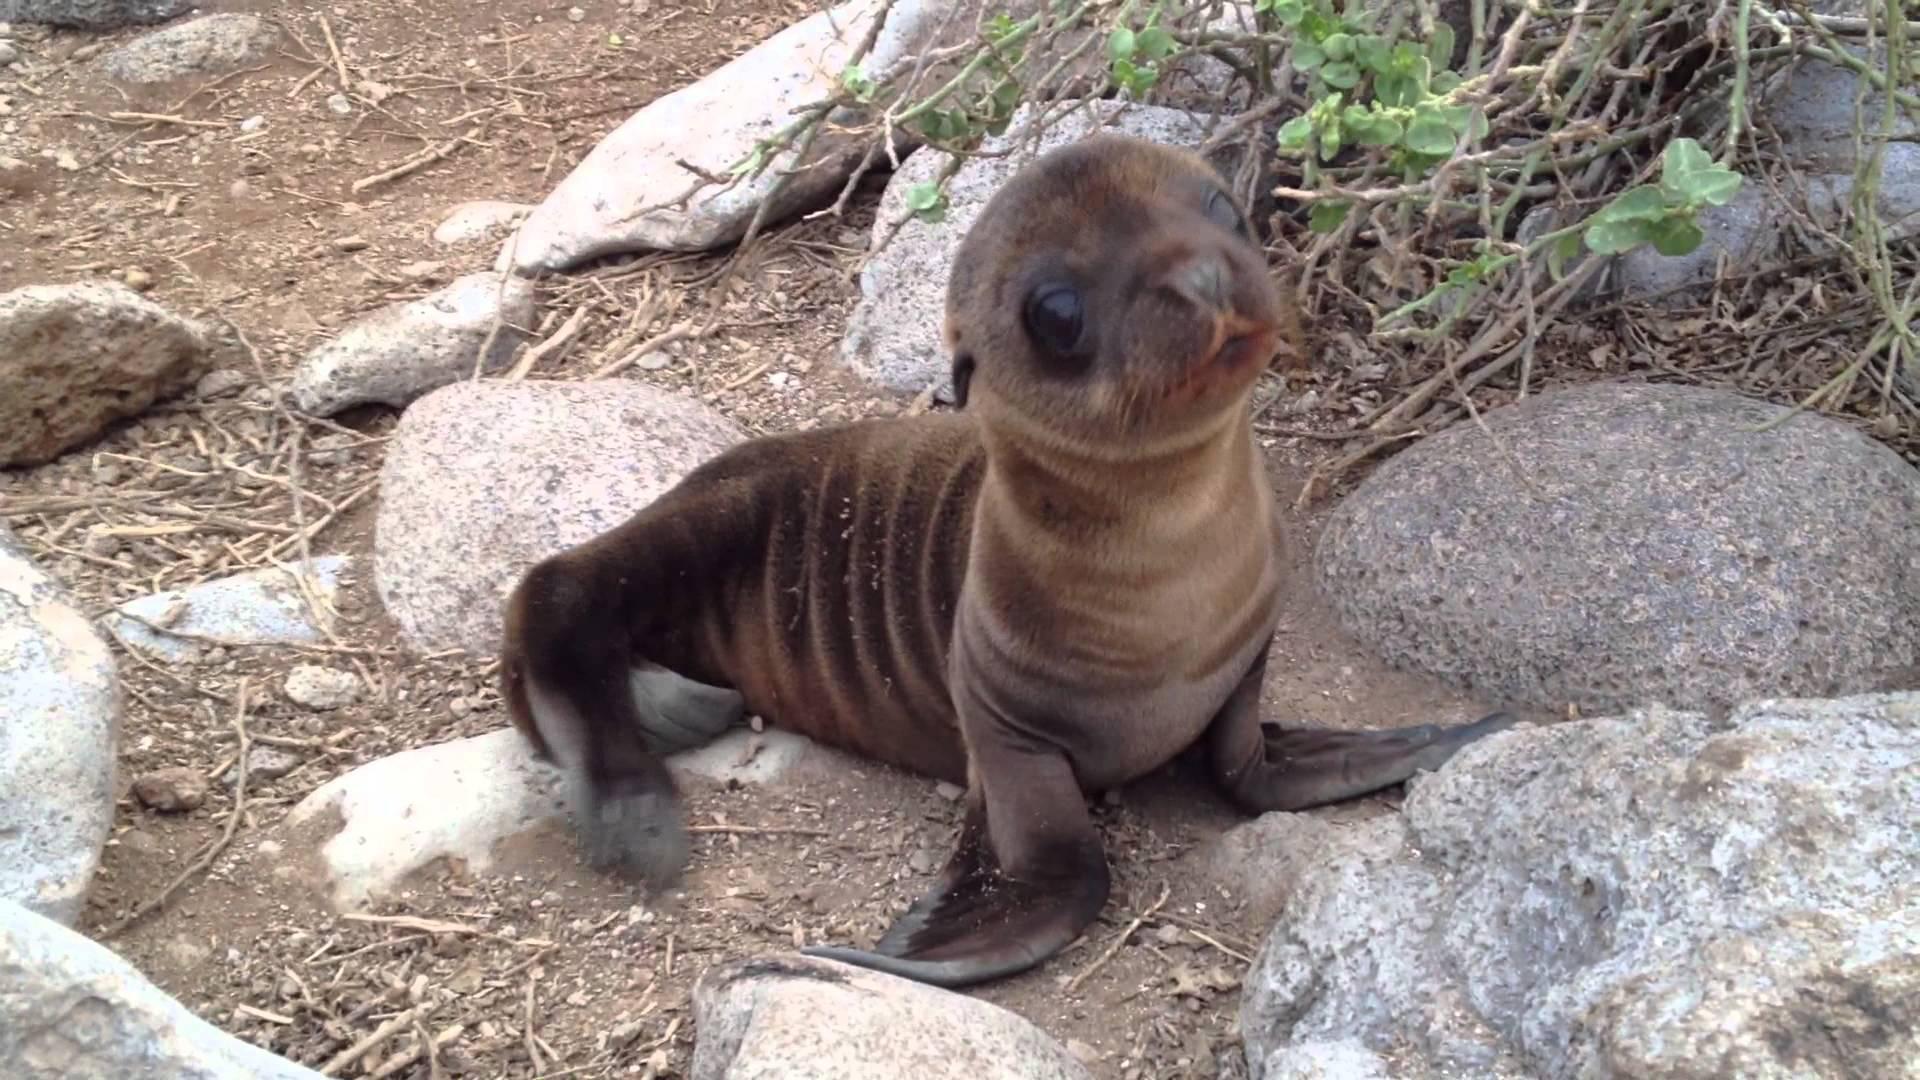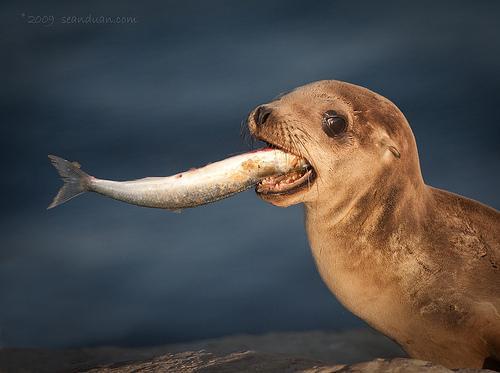The first image is the image on the left, the second image is the image on the right. Considering the images on both sides, is "the baby seal on the right is lying down." valid? Answer yes or no. No. 